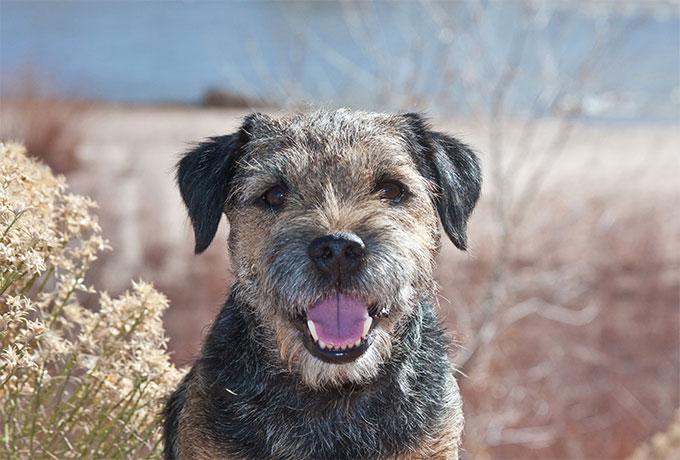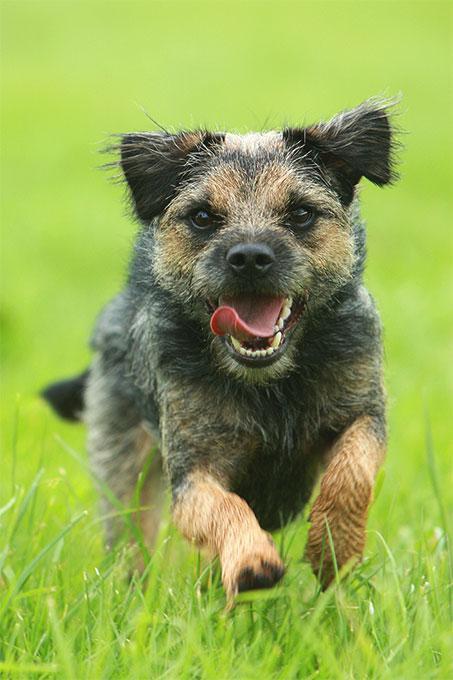The first image is the image on the left, the second image is the image on the right. Assess this claim about the two images: "At least one image shows one dog standing on grass in profile with pointing tail.". Correct or not? Answer yes or no. No. The first image is the image on the left, the second image is the image on the right. For the images displayed, is the sentence "Three dogs are standing in profile with their tails extended." factually correct? Answer yes or no. No. The first image is the image on the left, the second image is the image on the right. Given the left and right images, does the statement "A dog stands in profile on the grass with its tail extended." hold true? Answer yes or no. No. 